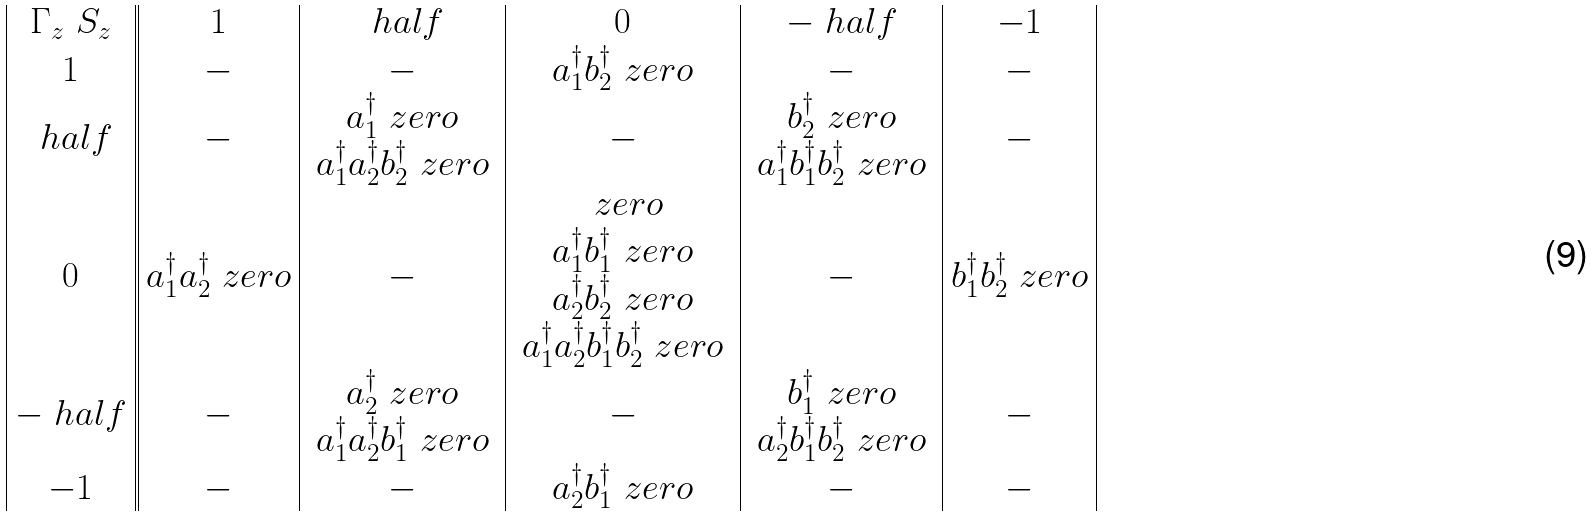Convert formula to latex. <formula><loc_0><loc_0><loc_500><loc_500>\begin{array} { | c | | c | c | c | c | c | } \Gamma _ { z } \ S _ { z } & 1 & \ h a l f & 0 & - \ h a l f & - 1 \\ 1 & - & - & a _ { 1 } ^ { \dagger } b _ { 2 } ^ { \dagger } \ z e r o & - & - \\ \ h a l f & - & \begin{array} { c } a _ { 1 } ^ { \dagger } \ z e r o \\ a _ { 1 } ^ { \dagger } a _ { 2 } ^ { \dagger } b _ { 2 } ^ { \dagger } \ z e r o \end{array} & - & \begin{array} { c } b _ { 2 } ^ { \dagger } \ z e r o \\ a _ { 1 } ^ { \dagger } b _ { 1 } ^ { \dagger } b _ { 2 } ^ { \dagger } \ z e r o \end{array} & - \\ 0 & a _ { 1 } ^ { \dagger } a _ { 2 } ^ { \dagger } \ z e r o & - & \begin{array} { c } \ z e r o \\ a _ { 1 } ^ { \dagger } b _ { 1 } ^ { \dagger } \ z e r o \\ a _ { 2 } ^ { \dagger } b _ { 2 } ^ { \dagger } \ z e r o \\ a _ { 1 } ^ { \dagger } a _ { 2 } ^ { \dagger } b _ { 1 } ^ { \dagger } b _ { 2 } ^ { \dagger } \ z e r o \end{array} & - & b _ { 1 } ^ { \dagger } b _ { 2 } ^ { \dagger } \ z e r o \\ - \ h a l f & - & \begin{array} { c } a _ { 2 } ^ { \dagger } \ z e r o \\ a _ { 1 } ^ { \dagger } a _ { 2 } ^ { \dagger } b _ { 1 } ^ { \dagger } \ z e r o \end{array} & - & \begin{array} { c } b _ { 1 } ^ { \dagger } \ z e r o \\ a _ { 2 } ^ { \dagger } b _ { 1 } ^ { \dagger } b _ { 2 } ^ { \dagger } \ z e r o \end{array} & - \\ - 1 & - & - & a _ { 2 } ^ { \dagger } b _ { 1 } ^ { \dagger } \ z e r o & - & - \\ \end{array}</formula> 